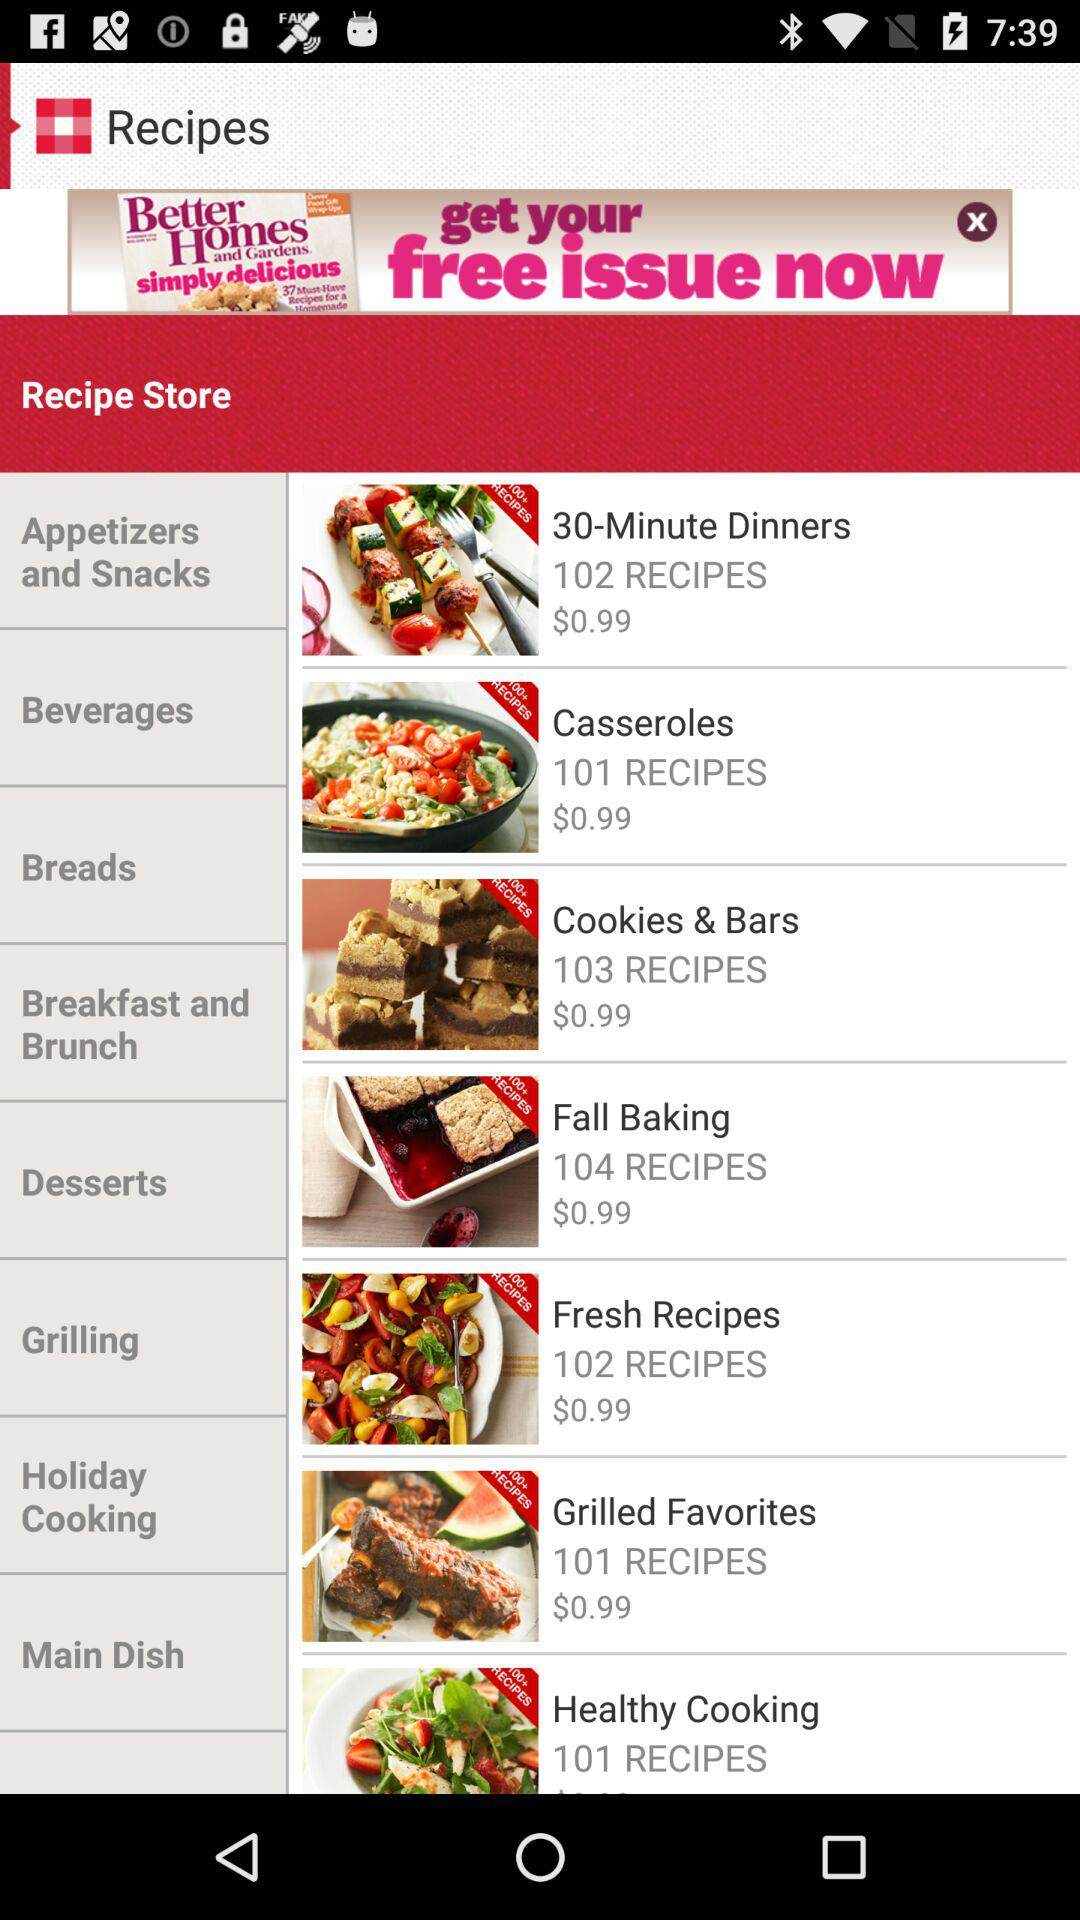How many recipes are there in "30-Minute Dinners"? There are 102 recipes in "30-Minute Dinners". 